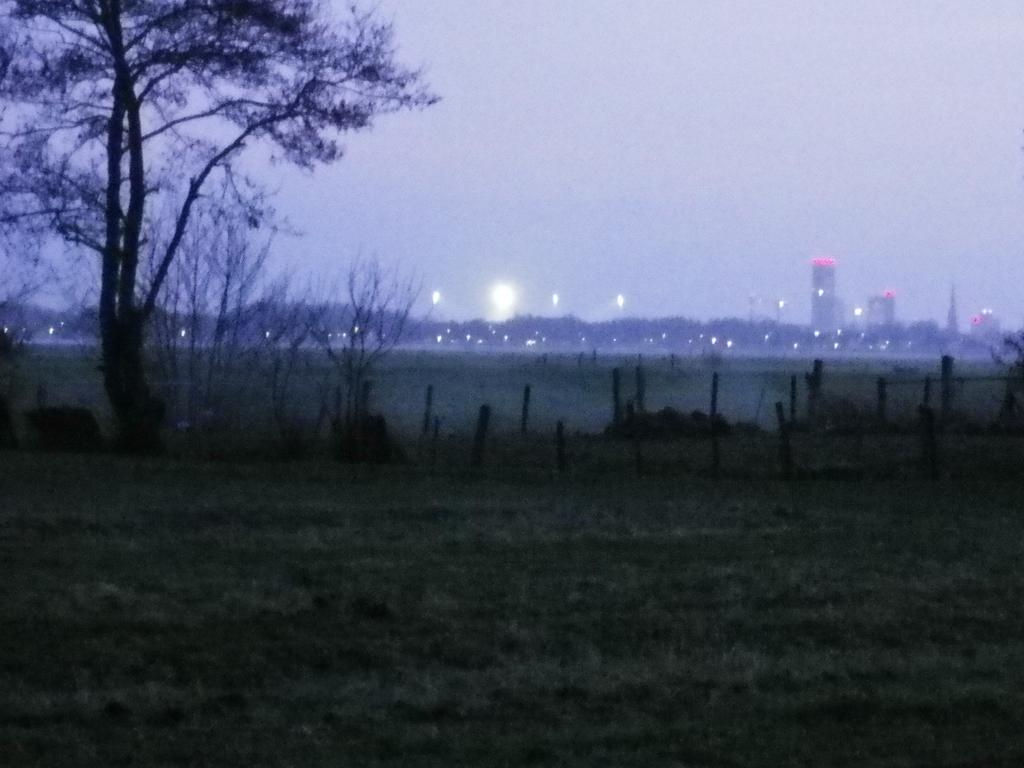What is the lighting condition in the image? The image was taken in dim light after sunset. What natural element can be seen in the image? There is a tree in the image. What type of man-made structures are visible in the image? There are tall buildings in the image. What type of magic is being performed on the desk in the image? There is no desk or magic present in the image. 